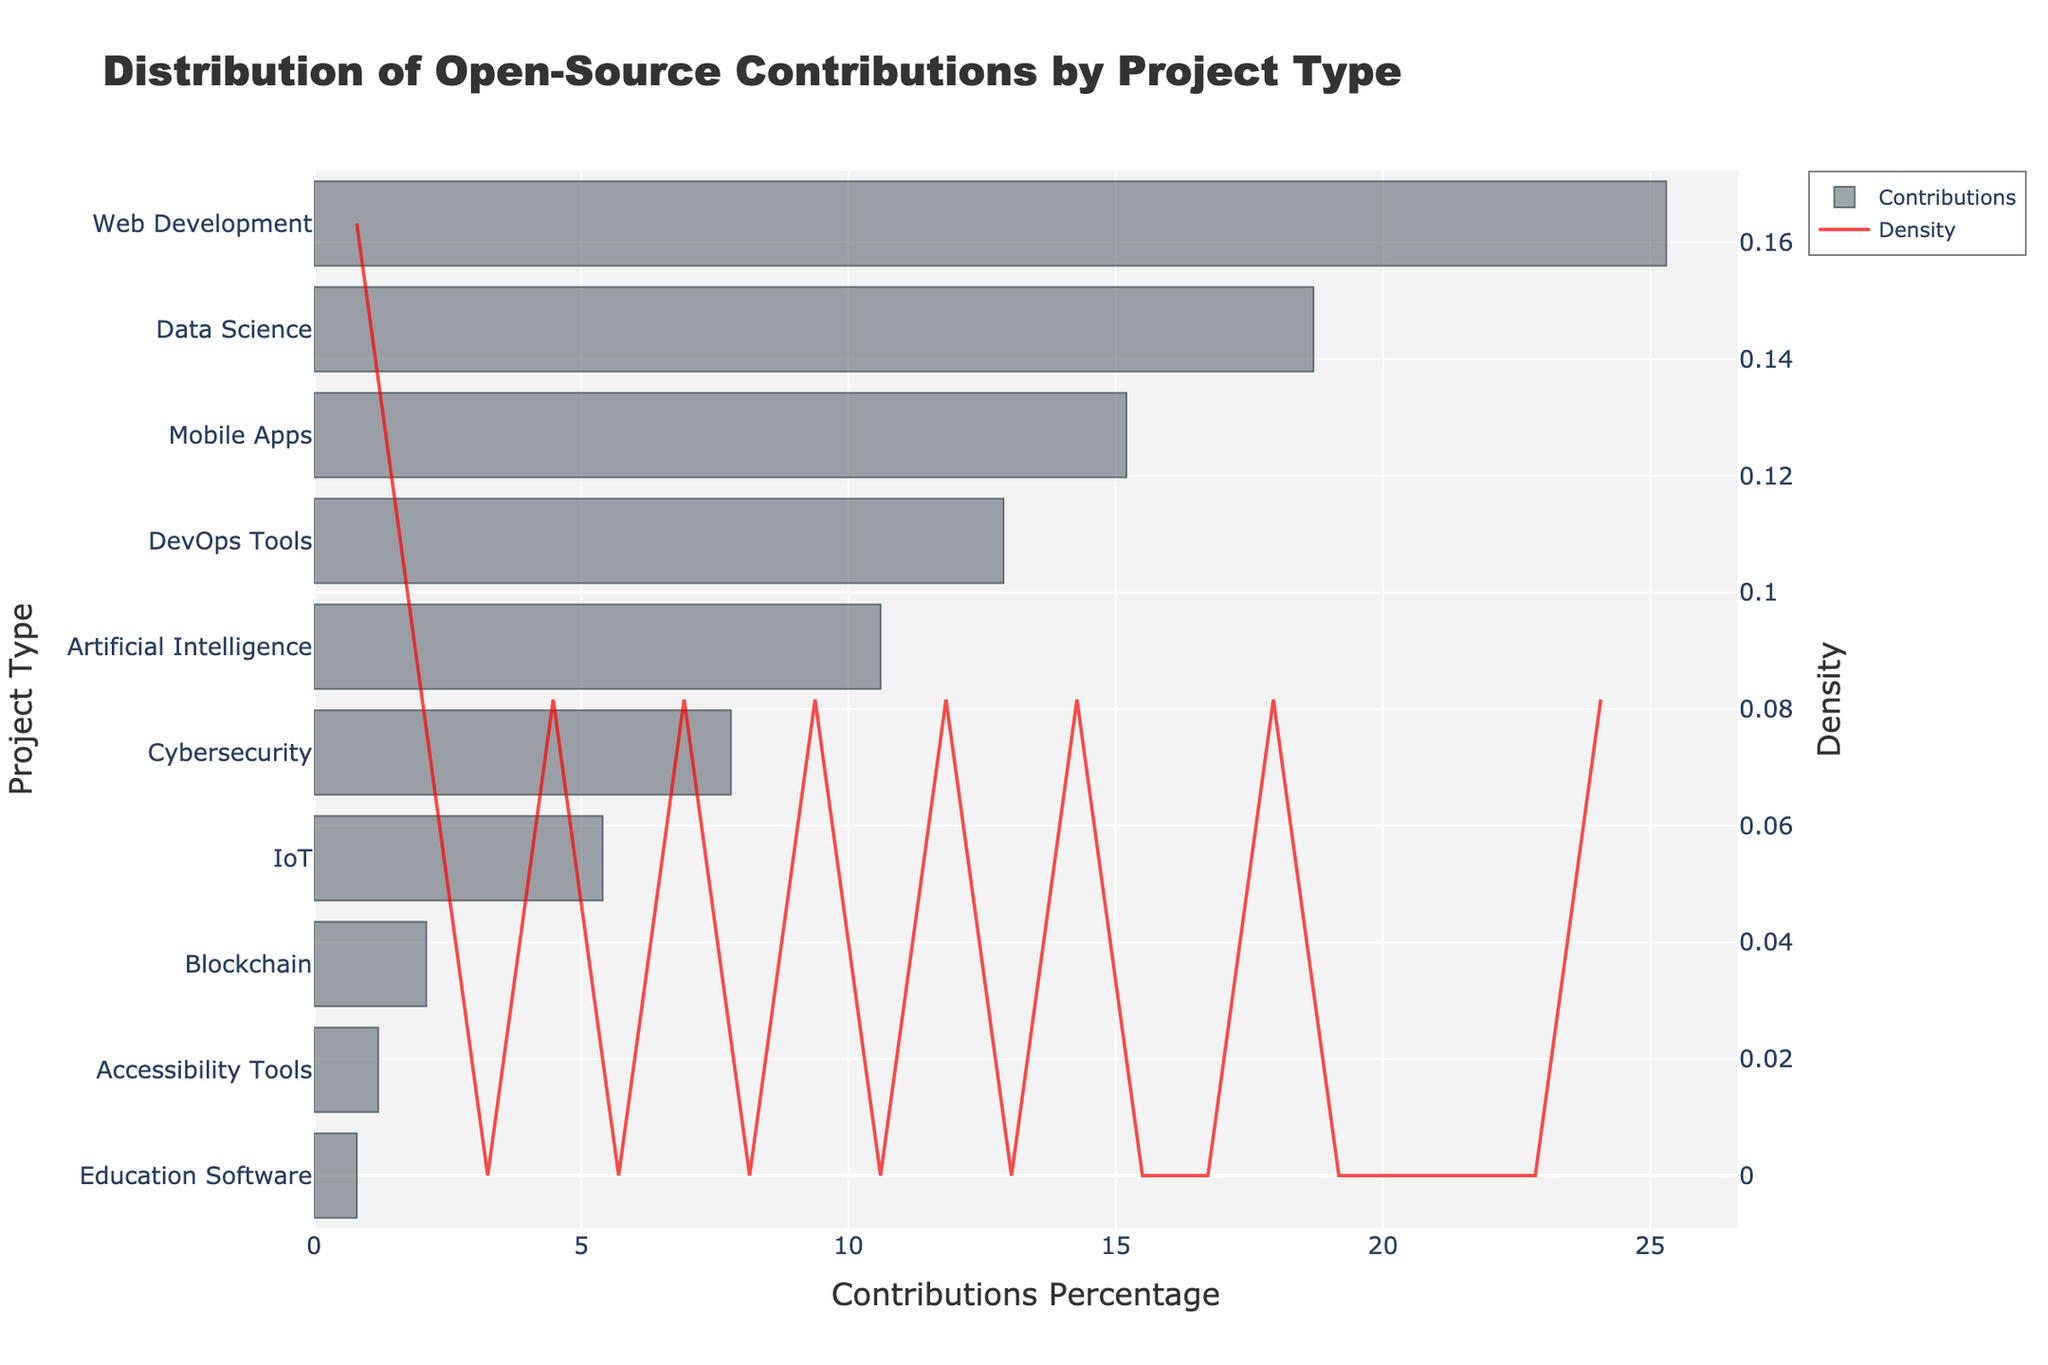Which project type has the highest percentage of contributions? The project type with the highest bar represents the highest percentage of contributions. In this histogram, the bar corresponding to "Web Development" is the highest.
Answer: Web Development What is the approximate percentage of contributions for Data Science projects? Locate the bar corresponding to "Data Science" on the y-axis, then check the x-axis value where the bar ends. The bar ends at approximately 18.7%.
Answer: 18.7% How many project types have contribution percentages below 10%? Count the number of bars that end below the 10% mark on the x-axis. The project types are Artificial Intelligence, Cybersecurity, IoT, Blockchain, Accessibility Tools, and Education Software. There are six such project types.
Answer: 6 Which project type has the lowest density of contributions? Examine the KDE curve on the density y-axis. The lowest density occurs at the rightmost point where the KDE curve touches the x-axis, which corresponds to the highest contribution percentages. The project type here is "Education Software."
Answer: Education Software Compare the percentage contributions of Mobile Apps and DevOps Tools. Which one is higher and by how much? Identify the bars for "Mobile Apps" and "DevOps Tools" on the y-axis and compare their corresponding x-axis values. Mobile Apps has 15.2% and DevOps Tools has 12.9%. Subtract the smaller value from the larger value: 15.2% - 12.9% = 2.3%.
Answer: Mobile Apps is higher by 2.3% What is the combined contribution percentage of Artificial Intelligence and Cybersecurity projects? Locate the bars for "Artificial Intelligence" and "Cybersecurity" on the y-axis. Summing their x-axis values gives: 10.6% + 7.8% = 18.4%.
Answer: 18.4% Is the distribution of contributions across project types more skewed towards higher or lower percentages? Examine the KDE curve. If the peak of the curve is closer to the lower percentages, the distribution is skewed towards lower percentages. In this case, the peak is towards the lower percentages.
Answer: Lower percentages 